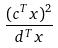<formula> <loc_0><loc_0><loc_500><loc_500>\frac { ( c ^ { T } x ) ^ { 2 } } { d ^ { T } x }</formula> 